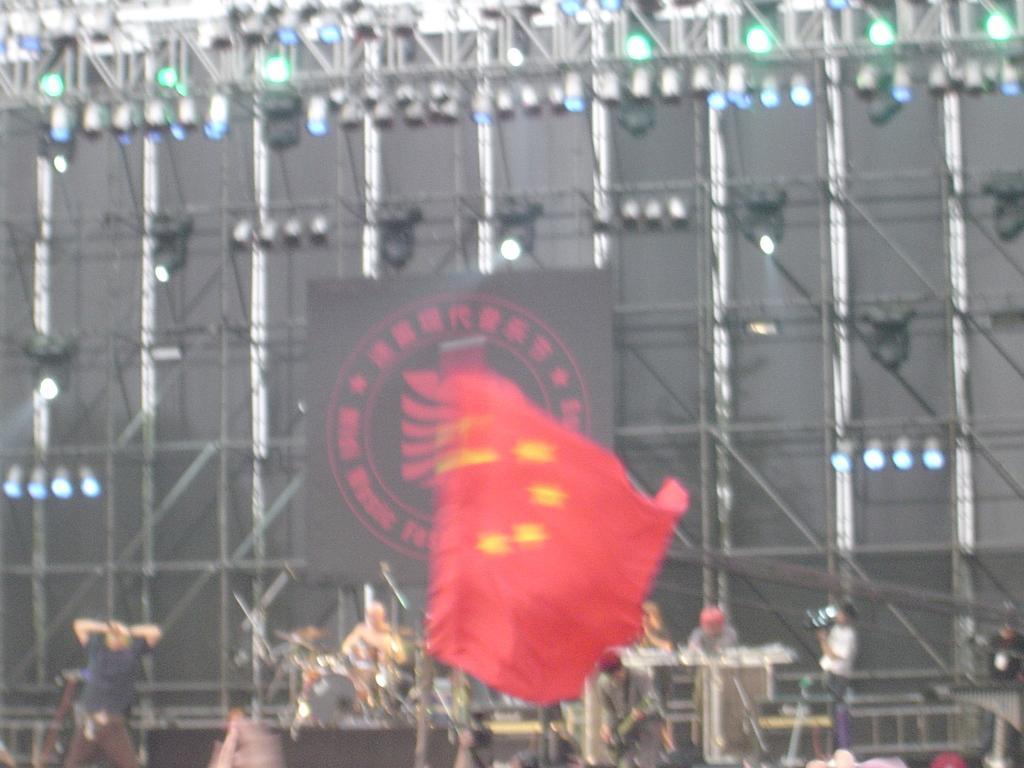Describe this image in one or two sentences. This image consists of a dais. On which there are few persons playing music. In the middle, we can see a red flag. In the background, there is a stand to which there are lamps hanged. And we can see a banner. 